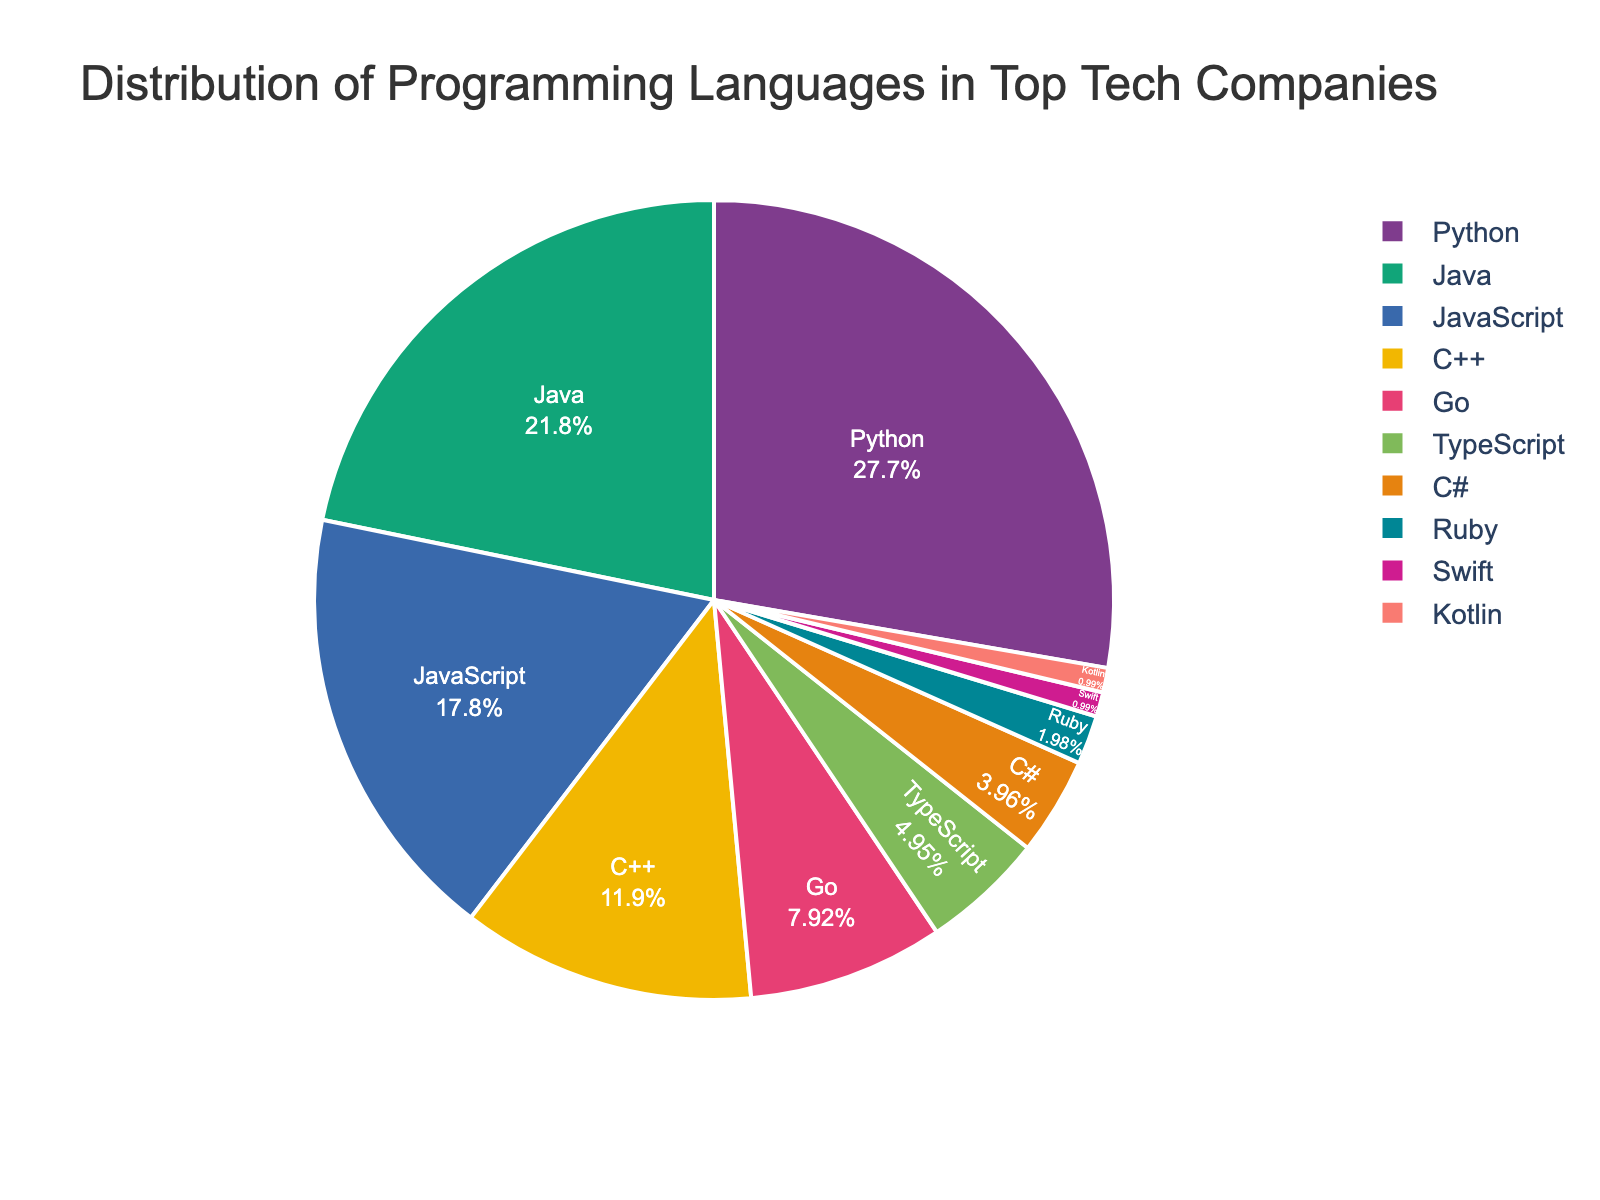What is the most commonly used programming language in top tech companies? The figure shows the distribution of programming languages used, with Python having the largest segment at 28%. Therefore, Python is the most commonly used programming language.
Answer: Python Which two programming languages together account for exactly half of the distribution? The figure indicates the percentages for each language. Adding Python (28%) and Java (22%) gives 50%, which is exactly half of the total distribution.
Answer: Python and Java How much more popular is JavaScript compared to Ruby? The figure shows JavaScript at 18% and Ruby at 2%. Subtracting these values gives 18% - 2% = 16%.
Answer: 16% Which language has the smallest usage percentage and what is it? The figure clearly shows that both Swift and Kotlin have the smallest segments, each accounting for 1% of the distribution.
Answer: Swift and Kotlin What is the combined percentage of TypeScript, C#, and Ruby? To find the combined percentage, add the values for TypeScript (5%), C# (4%), and Ruby (2%). This results in 5% + 4% + 2% = 11%.
Answer: 11% By how much does the percentage usage of Go exceed that of Swift? The figure shows Go at 8% and Swift at 1%. Subtracting these values gives 8% - 1% = 7%.
Answer: 7% If you grouped all languages with less than 10% usage, what would their total percentage be? Summing up C++ (12%), Go (8%), TypeScript (5%), C# (4%), Ruby (2%), Swift (1%), and Kotlin (1%), the combined total for languages under 10% would be 8% + 5% + 4% + 2% + 1% + 1% = 21%.
Answer: 21% What is the median percentage of usage for these programming languages? Ordering the percentages: [1, 1, 2, 4, 5, 8, 12, 18, 22, 28]. Since there are 10 data points, the median is the average of the 5th and 6th values (5 and 8). Thus, the median is (5+8)/2 = 6.5%.
Answer: 6.5% What is the difference between the most commonly used language and the least commonly used languages combined? Python is the most used at 28%, while Swift and Kotlin are each at 1%. The combined percentage of Swift and Kotlin is 1% + 1% = 2%. Therefore, the difference is 28% - 2% = 26%.
Answer: 26% Which languages have a usage percentage greater than 15%? The languages with percentages over 15% are Python (28%), Java (22%), and JavaScript (18%).
Answer: Python, Java, JavaScript 